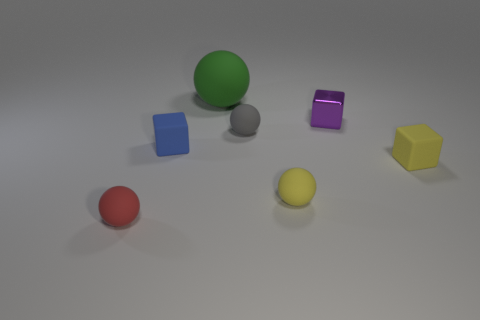Are there any other things that have the same size as the green matte ball?
Make the answer very short. No. Is there anything else that is made of the same material as the small purple thing?
Offer a very short reply. No. There is a gray rubber thing; is it the same size as the sphere behind the purple thing?
Keep it short and to the point. No. How many big objects are either gray metallic things or blue objects?
Offer a terse response. 0. What number of big green blocks are there?
Provide a succinct answer. 0. There is a cube behind the gray rubber ball; what is its material?
Your answer should be very brief. Metal. There is a purple shiny block; are there any tiny yellow rubber spheres behind it?
Keep it short and to the point. No. Is the size of the blue rubber object the same as the green object?
Offer a terse response. No. How many yellow balls are the same material as the green sphere?
Make the answer very short. 1. How big is the green object left of the small object that is on the right side of the small shiny cube?
Your response must be concise. Large. 